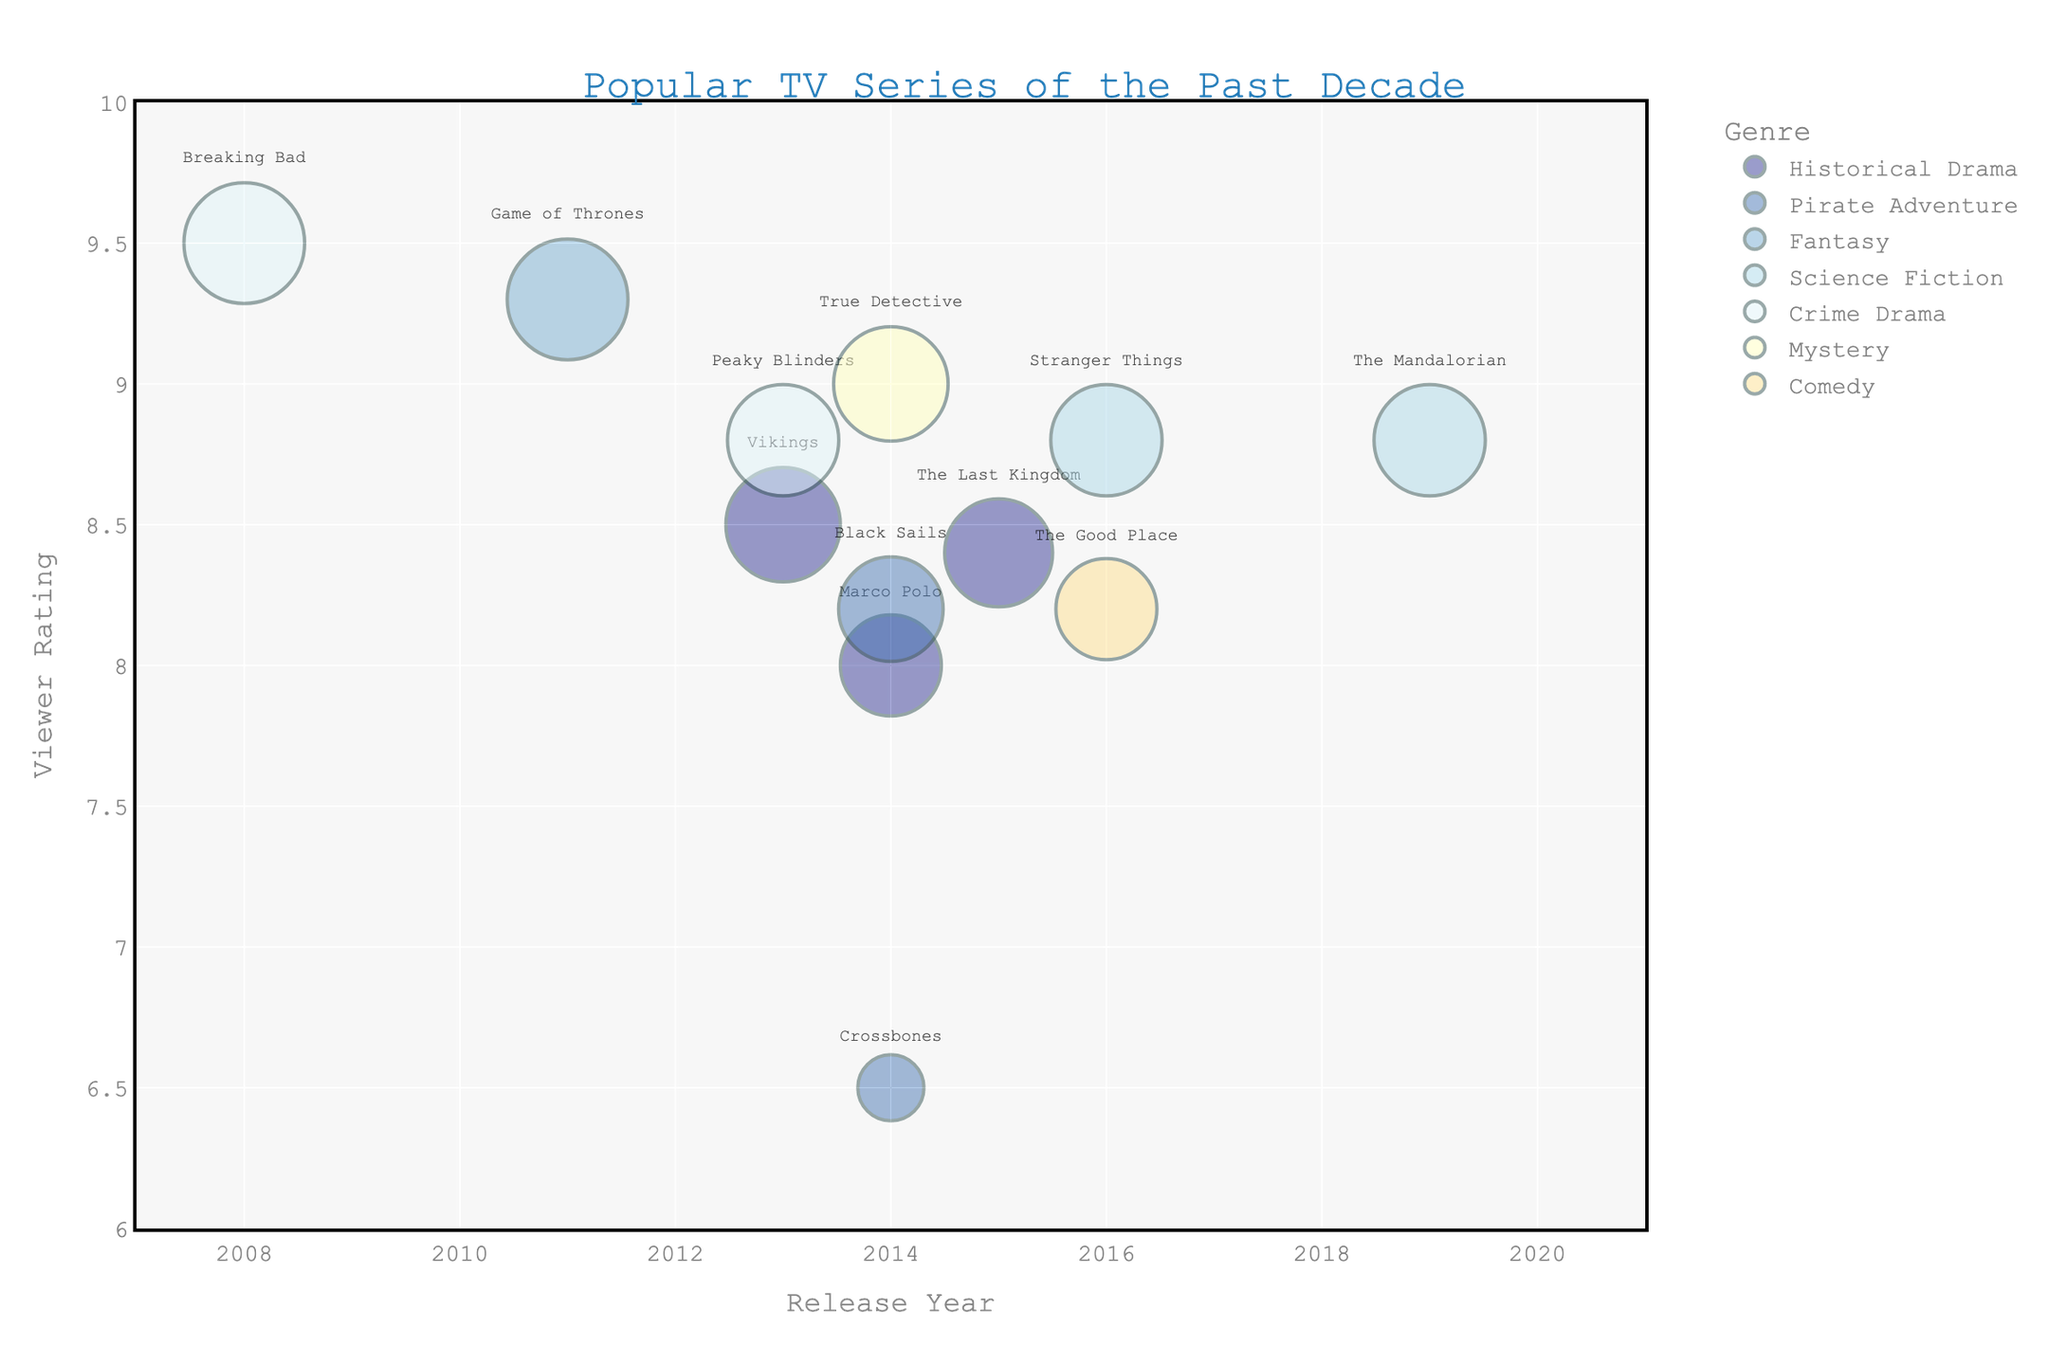What's the title of the bubble chart? The title is located at the top-center of the chart and typically indicates what the chart is about.
Answer: "Popular TV Series of the Past Decade" How many TV series are classified under "Historical Drama"? By observing the legend and counting the bubbles labeled with "Historical Drama" as a genre.
Answer: 3 Which TV series has the highest viewer rating, and what is its rating? Look for the bubble with the highest position on the y-axis.
Answer: "Breaking Bad" with a rating of 9.5 What's the average viewer rating of the "Science Fiction" TV series? Identify the bubbles for "Science Fiction" (Stranger Things and The Mandalorian), sum their viewer ratings (8.8 + 8.8), and divide by the count (2).
Answer: 8.8 Which genres have a viewer rating greater than 9.0? Identify the bubbles positioned above the 9.0 mark on the y-axis and refer to their genres.
Answer: Crime Drama and Mystery Compare the bubble sizes of "Vikings" and "Game of Thrones." Which is larger? By comparing the visual sizes of the bubbles, identify which one appears bigger.
Answer: "Game of Thrones" How many TV series were released in 2014? Check the bubbles aligned vertically at the release year 2014 on the x-axis.
Answer: 4 Excluding "Breaking Bad," which TV series has the next highest viewer rating and what genre does it belong to? Look for the second-highest positioned bubble on the y-axis besides "Breaking Bad."
Answer: "True Detective" (Mystery) Which year has the most TV series represented in this chart, and how many are there? Count the number of bubbles vertically aligned for each year on the x-axis and identify the year with the maximum count.
Answer: 2014 with 4 TV series What is the difference in viewer ratings between "Peaky Blinders" and "Crossbones"? Subtract the viewer rating of "Crossbones" from that of "Peaky Blinders" (8.8 - 6.5).
Answer: 2.3 